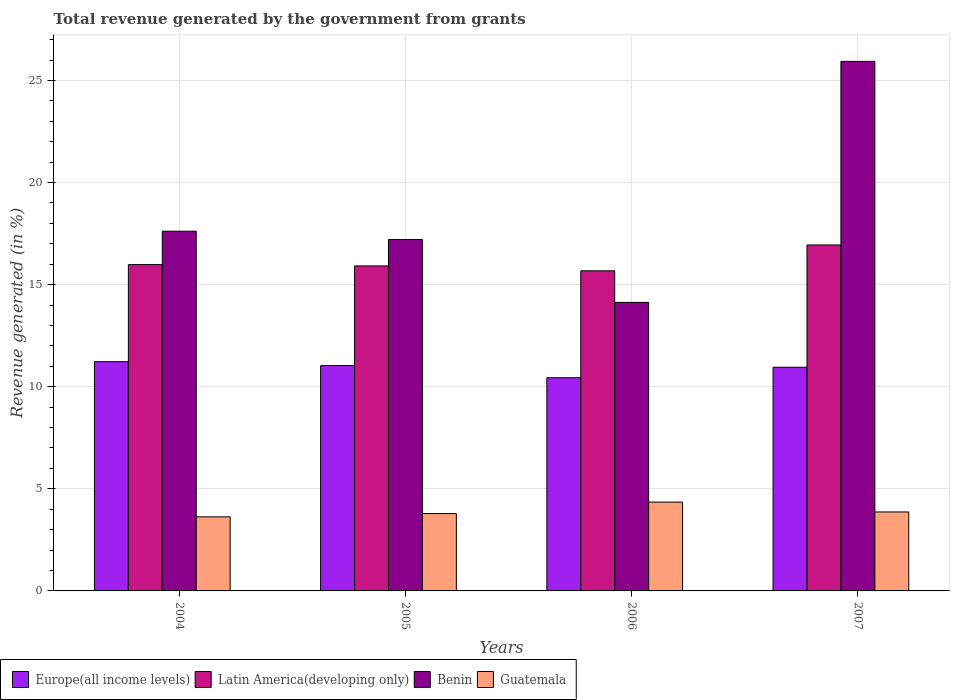How many different coloured bars are there?
Your answer should be compact. 4. Are the number of bars per tick equal to the number of legend labels?
Keep it short and to the point. Yes. Are the number of bars on each tick of the X-axis equal?
Make the answer very short. Yes. How many bars are there on the 1st tick from the left?
Your answer should be very brief. 4. How many bars are there on the 4th tick from the right?
Give a very brief answer. 4. What is the total revenue generated in Benin in 2004?
Keep it short and to the point. 17.62. Across all years, what is the maximum total revenue generated in Guatemala?
Make the answer very short. 4.35. Across all years, what is the minimum total revenue generated in Guatemala?
Offer a terse response. 3.63. In which year was the total revenue generated in Europe(all income levels) maximum?
Your answer should be compact. 2004. In which year was the total revenue generated in Europe(all income levels) minimum?
Provide a succinct answer. 2006. What is the total total revenue generated in Europe(all income levels) in the graph?
Make the answer very short. 43.66. What is the difference between the total revenue generated in Guatemala in 2005 and that in 2007?
Offer a terse response. -0.08. What is the difference between the total revenue generated in Europe(all income levels) in 2006 and the total revenue generated in Latin America(developing only) in 2004?
Your response must be concise. -5.54. What is the average total revenue generated in Guatemala per year?
Provide a succinct answer. 3.91. In the year 2005, what is the difference between the total revenue generated in Latin America(developing only) and total revenue generated in Guatemala?
Your response must be concise. 12.13. In how many years, is the total revenue generated in Benin greater than 8 %?
Give a very brief answer. 4. What is the ratio of the total revenue generated in Latin America(developing only) in 2005 to that in 2007?
Keep it short and to the point. 0.94. Is the total revenue generated in Latin America(developing only) in 2004 less than that in 2005?
Provide a short and direct response. No. What is the difference between the highest and the second highest total revenue generated in Guatemala?
Your answer should be very brief. 0.48. What is the difference between the highest and the lowest total revenue generated in Latin America(developing only)?
Give a very brief answer. 1.27. In how many years, is the total revenue generated in Europe(all income levels) greater than the average total revenue generated in Europe(all income levels) taken over all years?
Offer a terse response. 3. Is the sum of the total revenue generated in Benin in 2004 and 2006 greater than the maximum total revenue generated in Latin America(developing only) across all years?
Keep it short and to the point. Yes. What does the 2nd bar from the left in 2006 represents?
Make the answer very short. Latin America(developing only). What does the 3rd bar from the right in 2007 represents?
Give a very brief answer. Latin America(developing only). Are all the bars in the graph horizontal?
Provide a short and direct response. No. How many years are there in the graph?
Ensure brevity in your answer.  4. What is the difference between two consecutive major ticks on the Y-axis?
Make the answer very short. 5. Does the graph contain any zero values?
Your answer should be very brief. No. Where does the legend appear in the graph?
Keep it short and to the point. Bottom left. How are the legend labels stacked?
Your answer should be compact. Horizontal. What is the title of the graph?
Offer a terse response. Total revenue generated by the government from grants. What is the label or title of the X-axis?
Your response must be concise. Years. What is the label or title of the Y-axis?
Provide a short and direct response. Revenue generated (in %). What is the Revenue generated (in %) in Europe(all income levels) in 2004?
Your response must be concise. 11.23. What is the Revenue generated (in %) of Latin America(developing only) in 2004?
Your answer should be compact. 15.98. What is the Revenue generated (in %) in Benin in 2004?
Keep it short and to the point. 17.62. What is the Revenue generated (in %) of Guatemala in 2004?
Your answer should be compact. 3.63. What is the Revenue generated (in %) of Europe(all income levels) in 2005?
Provide a short and direct response. 11.04. What is the Revenue generated (in %) in Latin America(developing only) in 2005?
Your response must be concise. 15.92. What is the Revenue generated (in %) in Benin in 2005?
Your answer should be compact. 17.21. What is the Revenue generated (in %) of Guatemala in 2005?
Keep it short and to the point. 3.79. What is the Revenue generated (in %) in Europe(all income levels) in 2006?
Your response must be concise. 10.44. What is the Revenue generated (in %) in Latin America(developing only) in 2006?
Provide a short and direct response. 15.68. What is the Revenue generated (in %) of Benin in 2006?
Give a very brief answer. 14.13. What is the Revenue generated (in %) in Guatemala in 2006?
Your answer should be very brief. 4.35. What is the Revenue generated (in %) of Europe(all income levels) in 2007?
Your response must be concise. 10.96. What is the Revenue generated (in %) of Latin America(developing only) in 2007?
Ensure brevity in your answer.  16.94. What is the Revenue generated (in %) of Benin in 2007?
Provide a short and direct response. 25.94. What is the Revenue generated (in %) of Guatemala in 2007?
Offer a terse response. 3.87. Across all years, what is the maximum Revenue generated (in %) of Europe(all income levels)?
Keep it short and to the point. 11.23. Across all years, what is the maximum Revenue generated (in %) in Latin America(developing only)?
Your response must be concise. 16.94. Across all years, what is the maximum Revenue generated (in %) of Benin?
Ensure brevity in your answer.  25.94. Across all years, what is the maximum Revenue generated (in %) in Guatemala?
Keep it short and to the point. 4.35. Across all years, what is the minimum Revenue generated (in %) in Europe(all income levels)?
Provide a short and direct response. 10.44. Across all years, what is the minimum Revenue generated (in %) in Latin America(developing only)?
Offer a terse response. 15.68. Across all years, what is the minimum Revenue generated (in %) of Benin?
Your response must be concise. 14.13. Across all years, what is the minimum Revenue generated (in %) of Guatemala?
Ensure brevity in your answer.  3.63. What is the total Revenue generated (in %) in Europe(all income levels) in the graph?
Your answer should be compact. 43.66. What is the total Revenue generated (in %) in Latin America(developing only) in the graph?
Your response must be concise. 64.52. What is the total Revenue generated (in %) of Benin in the graph?
Give a very brief answer. 74.89. What is the total Revenue generated (in %) in Guatemala in the graph?
Your response must be concise. 15.63. What is the difference between the Revenue generated (in %) in Europe(all income levels) in 2004 and that in 2005?
Offer a terse response. 0.19. What is the difference between the Revenue generated (in %) in Latin America(developing only) in 2004 and that in 2005?
Provide a short and direct response. 0.06. What is the difference between the Revenue generated (in %) in Benin in 2004 and that in 2005?
Provide a succinct answer. 0.41. What is the difference between the Revenue generated (in %) in Guatemala in 2004 and that in 2005?
Offer a very short reply. -0.16. What is the difference between the Revenue generated (in %) of Europe(all income levels) in 2004 and that in 2006?
Offer a terse response. 0.79. What is the difference between the Revenue generated (in %) of Latin America(developing only) in 2004 and that in 2006?
Keep it short and to the point. 0.3. What is the difference between the Revenue generated (in %) of Benin in 2004 and that in 2006?
Give a very brief answer. 3.49. What is the difference between the Revenue generated (in %) in Guatemala in 2004 and that in 2006?
Keep it short and to the point. -0.72. What is the difference between the Revenue generated (in %) in Europe(all income levels) in 2004 and that in 2007?
Make the answer very short. 0.27. What is the difference between the Revenue generated (in %) of Latin America(developing only) in 2004 and that in 2007?
Offer a very short reply. -0.96. What is the difference between the Revenue generated (in %) in Benin in 2004 and that in 2007?
Your answer should be compact. -8.32. What is the difference between the Revenue generated (in %) of Guatemala in 2004 and that in 2007?
Offer a terse response. -0.24. What is the difference between the Revenue generated (in %) of Europe(all income levels) in 2005 and that in 2006?
Offer a terse response. 0.59. What is the difference between the Revenue generated (in %) of Latin America(developing only) in 2005 and that in 2006?
Give a very brief answer. 0.24. What is the difference between the Revenue generated (in %) of Benin in 2005 and that in 2006?
Keep it short and to the point. 3.08. What is the difference between the Revenue generated (in %) of Guatemala in 2005 and that in 2006?
Keep it short and to the point. -0.56. What is the difference between the Revenue generated (in %) of Europe(all income levels) in 2005 and that in 2007?
Ensure brevity in your answer.  0.08. What is the difference between the Revenue generated (in %) of Latin America(developing only) in 2005 and that in 2007?
Provide a short and direct response. -1.03. What is the difference between the Revenue generated (in %) of Benin in 2005 and that in 2007?
Keep it short and to the point. -8.73. What is the difference between the Revenue generated (in %) in Guatemala in 2005 and that in 2007?
Keep it short and to the point. -0.08. What is the difference between the Revenue generated (in %) of Europe(all income levels) in 2006 and that in 2007?
Give a very brief answer. -0.51. What is the difference between the Revenue generated (in %) of Latin America(developing only) in 2006 and that in 2007?
Offer a terse response. -1.26. What is the difference between the Revenue generated (in %) in Benin in 2006 and that in 2007?
Provide a short and direct response. -11.81. What is the difference between the Revenue generated (in %) in Guatemala in 2006 and that in 2007?
Your response must be concise. 0.48. What is the difference between the Revenue generated (in %) in Europe(all income levels) in 2004 and the Revenue generated (in %) in Latin America(developing only) in 2005?
Ensure brevity in your answer.  -4.69. What is the difference between the Revenue generated (in %) in Europe(all income levels) in 2004 and the Revenue generated (in %) in Benin in 2005?
Make the answer very short. -5.98. What is the difference between the Revenue generated (in %) of Europe(all income levels) in 2004 and the Revenue generated (in %) of Guatemala in 2005?
Keep it short and to the point. 7.44. What is the difference between the Revenue generated (in %) of Latin America(developing only) in 2004 and the Revenue generated (in %) of Benin in 2005?
Give a very brief answer. -1.23. What is the difference between the Revenue generated (in %) of Latin America(developing only) in 2004 and the Revenue generated (in %) of Guatemala in 2005?
Offer a very short reply. 12.19. What is the difference between the Revenue generated (in %) in Benin in 2004 and the Revenue generated (in %) in Guatemala in 2005?
Provide a succinct answer. 13.83. What is the difference between the Revenue generated (in %) of Europe(all income levels) in 2004 and the Revenue generated (in %) of Latin America(developing only) in 2006?
Keep it short and to the point. -4.45. What is the difference between the Revenue generated (in %) of Europe(all income levels) in 2004 and the Revenue generated (in %) of Benin in 2006?
Ensure brevity in your answer.  -2.9. What is the difference between the Revenue generated (in %) in Europe(all income levels) in 2004 and the Revenue generated (in %) in Guatemala in 2006?
Offer a terse response. 6.88. What is the difference between the Revenue generated (in %) of Latin America(developing only) in 2004 and the Revenue generated (in %) of Benin in 2006?
Keep it short and to the point. 1.85. What is the difference between the Revenue generated (in %) of Latin America(developing only) in 2004 and the Revenue generated (in %) of Guatemala in 2006?
Offer a terse response. 11.63. What is the difference between the Revenue generated (in %) of Benin in 2004 and the Revenue generated (in %) of Guatemala in 2006?
Keep it short and to the point. 13.27. What is the difference between the Revenue generated (in %) in Europe(all income levels) in 2004 and the Revenue generated (in %) in Latin America(developing only) in 2007?
Provide a short and direct response. -5.72. What is the difference between the Revenue generated (in %) of Europe(all income levels) in 2004 and the Revenue generated (in %) of Benin in 2007?
Make the answer very short. -14.71. What is the difference between the Revenue generated (in %) of Europe(all income levels) in 2004 and the Revenue generated (in %) of Guatemala in 2007?
Provide a short and direct response. 7.36. What is the difference between the Revenue generated (in %) in Latin America(developing only) in 2004 and the Revenue generated (in %) in Benin in 2007?
Your response must be concise. -9.95. What is the difference between the Revenue generated (in %) of Latin America(developing only) in 2004 and the Revenue generated (in %) of Guatemala in 2007?
Provide a succinct answer. 12.11. What is the difference between the Revenue generated (in %) of Benin in 2004 and the Revenue generated (in %) of Guatemala in 2007?
Provide a succinct answer. 13.75. What is the difference between the Revenue generated (in %) in Europe(all income levels) in 2005 and the Revenue generated (in %) in Latin America(developing only) in 2006?
Give a very brief answer. -4.64. What is the difference between the Revenue generated (in %) of Europe(all income levels) in 2005 and the Revenue generated (in %) of Benin in 2006?
Keep it short and to the point. -3.1. What is the difference between the Revenue generated (in %) in Europe(all income levels) in 2005 and the Revenue generated (in %) in Guatemala in 2006?
Ensure brevity in your answer.  6.69. What is the difference between the Revenue generated (in %) in Latin America(developing only) in 2005 and the Revenue generated (in %) in Benin in 2006?
Your answer should be very brief. 1.79. What is the difference between the Revenue generated (in %) in Latin America(developing only) in 2005 and the Revenue generated (in %) in Guatemala in 2006?
Provide a succinct answer. 11.57. What is the difference between the Revenue generated (in %) in Benin in 2005 and the Revenue generated (in %) in Guatemala in 2006?
Your answer should be very brief. 12.86. What is the difference between the Revenue generated (in %) of Europe(all income levels) in 2005 and the Revenue generated (in %) of Latin America(developing only) in 2007?
Your response must be concise. -5.91. What is the difference between the Revenue generated (in %) in Europe(all income levels) in 2005 and the Revenue generated (in %) in Benin in 2007?
Provide a succinct answer. -14.9. What is the difference between the Revenue generated (in %) in Europe(all income levels) in 2005 and the Revenue generated (in %) in Guatemala in 2007?
Your answer should be very brief. 7.17. What is the difference between the Revenue generated (in %) of Latin America(developing only) in 2005 and the Revenue generated (in %) of Benin in 2007?
Provide a short and direct response. -10.02. What is the difference between the Revenue generated (in %) in Latin America(developing only) in 2005 and the Revenue generated (in %) in Guatemala in 2007?
Provide a succinct answer. 12.05. What is the difference between the Revenue generated (in %) of Benin in 2005 and the Revenue generated (in %) of Guatemala in 2007?
Offer a terse response. 13.34. What is the difference between the Revenue generated (in %) in Europe(all income levels) in 2006 and the Revenue generated (in %) in Latin America(developing only) in 2007?
Offer a terse response. -6.5. What is the difference between the Revenue generated (in %) in Europe(all income levels) in 2006 and the Revenue generated (in %) in Benin in 2007?
Keep it short and to the point. -15.49. What is the difference between the Revenue generated (in %) in Europe(all income levels) in 2006 and the Revenue generated (in %) in Guatemala in 2007?
Your answer should be compact. 6.57. What is the difference between the Revenue generated (in %) of Latin America(developing only) in 2006 and the Revenue generated (in %) of Benin in 2007?
Give a very brief answer. -10.26. What is the difference between the Revenue generated (in %) in Latin America(developing only) in 2006 and the Revenue generated (in %) in Guatemala in 2007?
Offer a terse response. 11.81. What is the difference between the Revenue generated (in %) in Benin in 2006 and the Revenue generated (in %) in Guatemala in 2007?
Your answer should be very brief. 10.26. What is the average Revenue generated (in %) in Europe(all income levels) per year?
Offer a very short reply. 10.91. What is the average Revenue generated (in %) in Latin America(developing only) per year?
Keep it short and to the point. 16.13. What is the average Revenue generated (in %) in Benin per year?
Your response must be concise. 18.72. What is the average Revenue generated (in %) of Guatemala per year?
Keep it short and to the point. 3.91. In the year 2004, what is the difference between the Revenue generated (in %) in Europe(all income levels) and Revenue generated (in %) in Latin America(developing only)?
Your answer should be very brief. -4.75. In the year 2004, what is the difference between the Revenue generated (in %) in Europe(all income levels) and Revenue generated (in %) in Benin?
Your answer should be very brief. -6.39. In the year 2004, what is the difference between the Revenue generated (in %) in Europe(all income levels) and Revenue generated (in %) in Guatemala?
Provide a short and direct response. 7.6. In the year 2004, what is the difference between the Revenue generated (in %) in Latin America(developing only) and Revenue generated (in %) in Benin?
Give a very brief answer. -1.64. In the year 2004, what is the difference between the Revenue generated (in %) of Latin America(developing only) and Revenue generated (in %) of Guatemala?
Offer a terse response. 12.35. In the year 2004, what is the difference between the Revenue generated (in %) of Benin and Revenue generated (in %) of Guatemala?
Offer a terse response. 13.99. In the year 2005, what is the difference between the Revenue generated (in %) of Europe(all income levels) and Revenue generated (in %) of Latin America(developing only)?
Your response must be concise. -4.88. In the year 2005, what is the difference between the Revenue generated (in %) of Europe(all income levels) and Revenue generated (in %) of Benin?
Your answer should be compact. -6.17. In the year 2005, what is the difference between the Revenue generated (in %) in Europe(all income levels) and Revenue generated (in %) in Guatemala?
Offer a terse response. 7.25. In the year 2005, what is the difference between the Revenue generated (in %) of Latin America(developing only) and Revenue generated (in %) of Benin?
Make the answer very short. -1.29. In the year 2005, what is the difference between the Revenue generated (in %) of Latin America(developing only) and Revenue generated (in %) of Guatemala?
Offer a very short reply. 12.13. In the year 2005, what is the difference between the Revenue generated (in %) of Benin and Revenue generated (in %) of Guatemala?
Your answer should be compact. 13.42. In the year 2006, what is the difference between the Revenue generated (in %) of Europe(all income levels) and Revenue generated (in %) of Latin America(developing only)?
Your response must be concise. -5.24. In the year 2006, what is the difference between the Revenue generated (in %) in Europe(all income levels) and Revenue generated (in %) in Benin?
Your response must be concise. -3.69. In the year 2006, what is the difference between the Revenue generated (in %) in Europe(all income levels) and Revenue generated (in %) in Guatemala?
Provide a short and direct response. 6.09. In the year 2006, what is the difference between the Revenue generated (in %) in Latin America(developing only) and Revenue generated (in %) in Benin?
Make the answer very short. 1.55. In the year 2006, what is the difference between the Revenue generated (in %) of Latin America(developing only) and Revenue generated (in %) of Guatemala?
Offer a terse response. 11.33. In the year 2006, what is the difference between the Revenue generated (in %) of Benin and Revenue generated (in %) of Guatemala?
Your answer should be very brief. 9.78. In the year 2007, what is the difference between the Revenue generated (in %) in Europe(all income levels) and Revenue generated (in %) in Latin America(developing only)?
Your response must be concise. -5.99. In the year 2007, what is the difference between the Revenue generated (in %) in Europe(all income levels) and Revenue generated (in %) in Benin?
Give a very brief answer. -14.98. In the year 2007, what is the difference between the Revenue generated (in %) of Europe(all income levels) and Revenue generated (in %) of Guatemala?
Offer a terse response. 7.09. In the year 2007, what is the difference between the Revenue generated (in %) in Latin America(developing only) and Revenue generated (in %) in Benin?
Your answer should be very brief. -8.99. In the year 2007, what is the difference between the Revenue generated (in %) of Latin America(developing only) and Revenue generated (in %) of Guatemala?
Provide a short and direct response. 13.08. In the year 2007, what is the difference between the Revenue generated (in %) of Benin and Revenue generated (in %) of Guatemala?
Offer a terse response. 22.07. What is the ratio of the Revenue generated (in %) in Europe(all income levels) in 2004 to that in 2005?
Offer a very short reply. 1.02. What is the ratio of the Revenue generated (in %) in Benin in 2004 to that in 2005?
Provide a short and direct response. 1.02. What is the ratio of the Revenue generated (in %) in Guatemala in 2004 to that in 2005?
Your answer should be compact. 0.96. What is the ratio of the Revenue generated (in %) of Europe(all income levels) in 2004 to that in 2006?
Offer a very short reply. 1.08. What is the ratio of the Revenue generated (in %) in Latin America(developing only) in 2004 to that in 2006?
Your response must be concise. 1.02. What is the ratio of the Revenue generated (in %) in Benin in 2004 to that in 2006?
Provide a short and direct response. 1.25. What is the ratio of the Revenue generated (in %) in Guatemala in 2004 to that in 2006?
Offer a very short reply. 0.83. What is the ratio of the Revenue generated (in %) of Europe(all income levels) in 2004 to that in 2007?
Keep it short and to the point. 1.02. What is the ratio of the Revenue generated (in %) in Latin America(developing only) in 2004 to that in 2007?
Make the answer very short. 0.94. What is the ratio of the Revenue generated (in %) in Benin in 2004 to that in 2007?
Your response must be concise. 0.68. What is the ratio of the Revenue generated (in %) in Guatemala in 2004 to that in 2007?
Your answer should be very brief. 0.94. What is the ratio of the Revenue generated (in %) in Europe(all income levels) in 2005 to that in 2006?
Offer a very short reply. 1.06. What is the ratio of the Revenue generated (in %) in Latin America(developing only) in 2005 to that in 2006?
Your response must be concise. 1.02. What is the ratio of the Revenue generated (in %) in Benin in 2005 to that in 2006?
Offer a terse response. 1.22. What is the ratio of the Revenue generated (in %) of Guatemala in 2005 to that in 2006?
Keep it short and to the point. 0.87. What is the ratio of the Revenue generated (in %) in Europe(all income levels) in 2005 to that in 2007?
Make the answer very short. 1.01. What is the ratio of the Revenue generated (in %) of Latin America(developing only) in 2005 to that in 2007?
Make the answer very short. 0.94. What is the ratio of the Revenue generated (in %) in Benin in 2005 to that in 2007?
Offer a terse response. 0.66. What is the ratio of the Revenue generated (in %) of Guatemala in 2005 to that in 2007?
Your answer should be very brief. 0.98. What is the ratio of the Revenue generated (in %) of Europe(all income levels) in 2006 to that in 2007?
Provide a short and direct response. 0.95. What is the ratio of the Revenue generated (in %) of Latin America(developing only) in 2006 to that in 2007?
Offer a very short reply. 0.93. What is the ratio of the Revenue generated (in %) in Benin in 2006 to that in 2007?
Give a very brief answer. 0.54. What is the ratio of the Revenue generated (in %) in Guatemala in 2006 to that in 2007?
Your response must be concise. 1.12. What is the difference between the highest and the second highest Revenue generated (in %) of Europe(all income levels)?
Make the answer very short. 0.19. What is the difference between the highest and the second highest Revenue generated (in %) in Latin America(developing only)?
Your answer should be very brief. 0.96. What is the difference between the highest and the second highest Revenue generated (in %) in Benin?
Make the answer very short. 8.32. What is the difference between the highest and the second highest Revenue generated (in %) in Guatemala?
Provide a succinct answer. 0.48. What is the difference between the highest and the lowest Revenue generated (in %) in Europe(all income levels)?
Make the answer very short. 0.79. What is the difference between the highest and the lowest Revenue generated (in %) of Latin America(developing only)?
Make the answer very short. 1.26. What is the difference between the highest and the lowest Revenue generated (in %) in Benin?
Provide a succinct answer. 11.81. What is the difference between the highest and the lowest Revenue generated (in %) in Guatemala?
Offer a terse response. 0.72. 